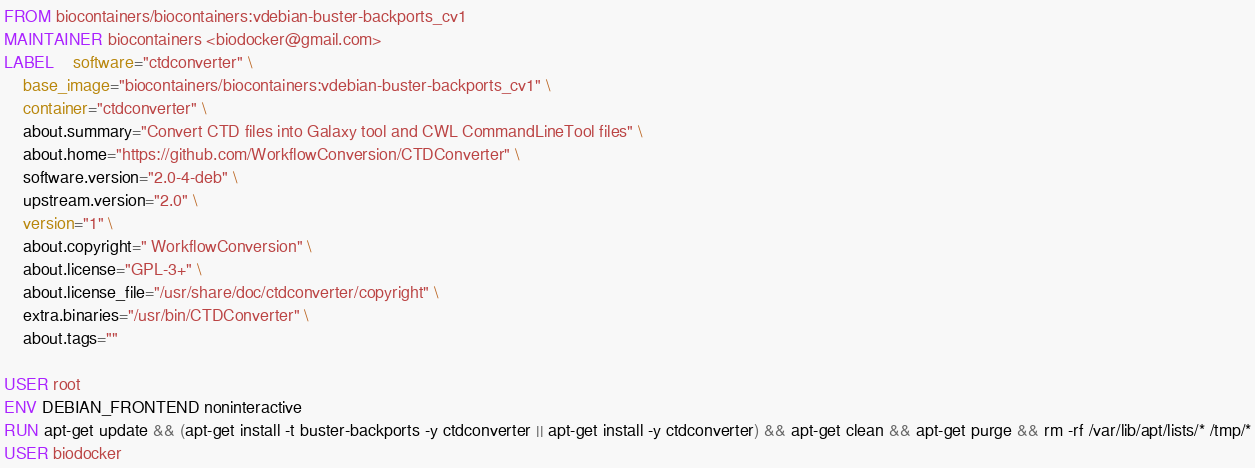<code> <loc_0><loc_0><loc_500><loc_500><_Dockerfile_>FROM biocontainers/biocontainers:vdebian-buster-backports_cv1
MAINTAINER biocontainers <biodocker@gmail.com>
LABEL    software="ctdconverter" \ 
    base_image="biocontainers/biocontainers:vdebian-buster-backports_cv1" \ 
    container="ctdconverter" \ 
    about.summary="Convert CTD files into Galaxy tool and CWL CommandLineTool files" \ 
    about.home="https://github.com/WorkflowConversion/CTDConverter" \ 
    software.version="2.0-4-deb" \ 
    upstream.version="2.0" \ 
    version="1" \ 
    about.copyright=" WorkflowConversion" \ 
    about.license="GPL-3+" \ 
    about.license_file="/usr/share/doc/ctdconverter/copyright" \ 
    extra.binaries="/usr/bin/CTDConverter" \ 
    about.tags=""

USER root
ENV DEBIAN_FRONTEND noninteractive
RUN apt-get update && (apt-get install -t buster-backports -y ctdconverter || apt-get install -y ctdconverter) && apt-get clean && apt-get purge && rm -rf /var/lib/apt/lists/* /tmp/*
USER biodocker
</code> 